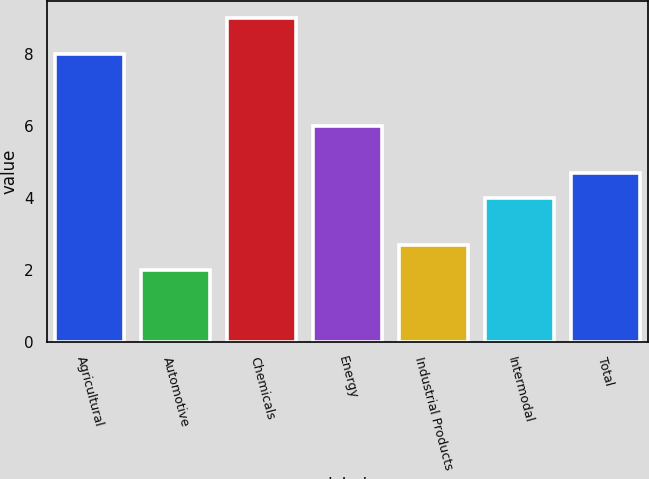Convert chart. <chart><loc_0><loc_0><loc_500><loc_500><bar_chart><fcel>Agricultural<fcel>Automotive<fcel>Chemicals<fcel>Energy<fcel>Industrial Products<fcel>Intermodal<fcel>Total<nl><fcel>8<fcel>2<fcel>9<fcel>6<fcel>2.7<fcel>4<fcel>4.7<nl></chart> 